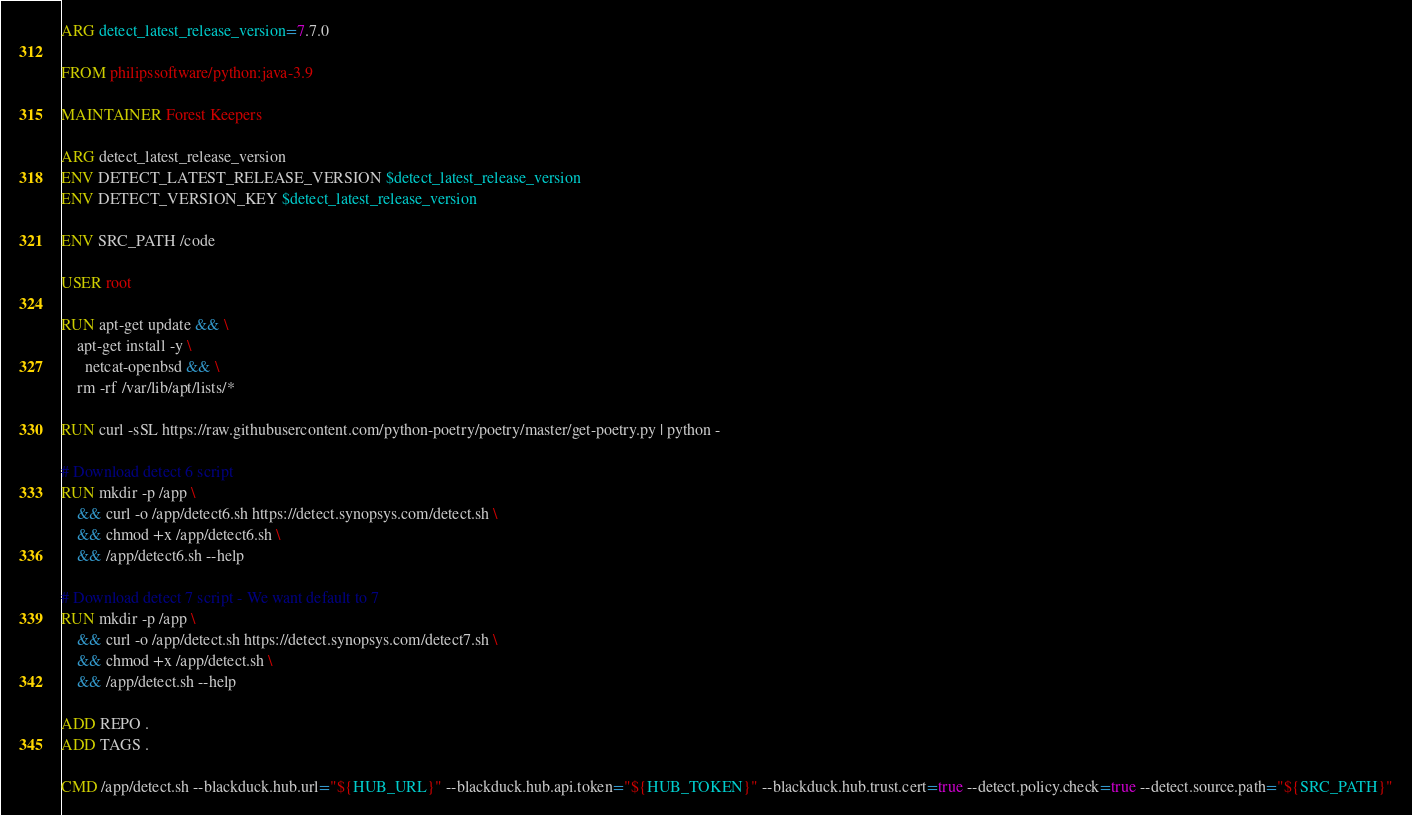<code> <loc_0><loc_0><loc_500><loc_500><_Dockerfile_>ARG detect_latest_release_version=7.7.0

FROM philipssoftware/python:java-3.9

MAINTAINER Forest Keepers

ARG detect_latest_release_version
ENV DETECT_LATEST_RELEASE_VERSION $detect_latest_release_version
ENV DETECT_VERSION_KEY $detect_latest_release_version

ENV SRC_PATH /code

USER root

RUN apt-get update && \
    apt-get install -y \
      netcat-openbsd && \
    rm -rf /var/lib/apt/lists/*

RUN curl -sSL https://raw.githubusercontent.com/python-poetry/poetry/master/get-poetry.py | python -

# Download detect 6 script
RUN mkdir -p /app \
    && curl -o /app/detect6.sh https://detect.synopsys.com/detect.sh \
    && chmod +x /app/detect6.sh \
    && /app/detect6.sh --help

# Download detect 7 script - We want default to 7
RUN mkdir -p /app \
    && curl -o /app/detect.sh https://detect.synopsys.com/detect7.sh \
    && chmod +x /app/detect.sh \
    && /app/detect.sh --help

ADD REPO .
ADD TAGS .

CMD /app/detect.sh --blackduck.hub.url="${HUB_URL}" --blackduck.hub.api.token="${HUB_TOKEN}" --blackduck.hub.trust.cert=true --detect.policy.check=true --detect.source.path="${SRC_PATH}"
</code> 